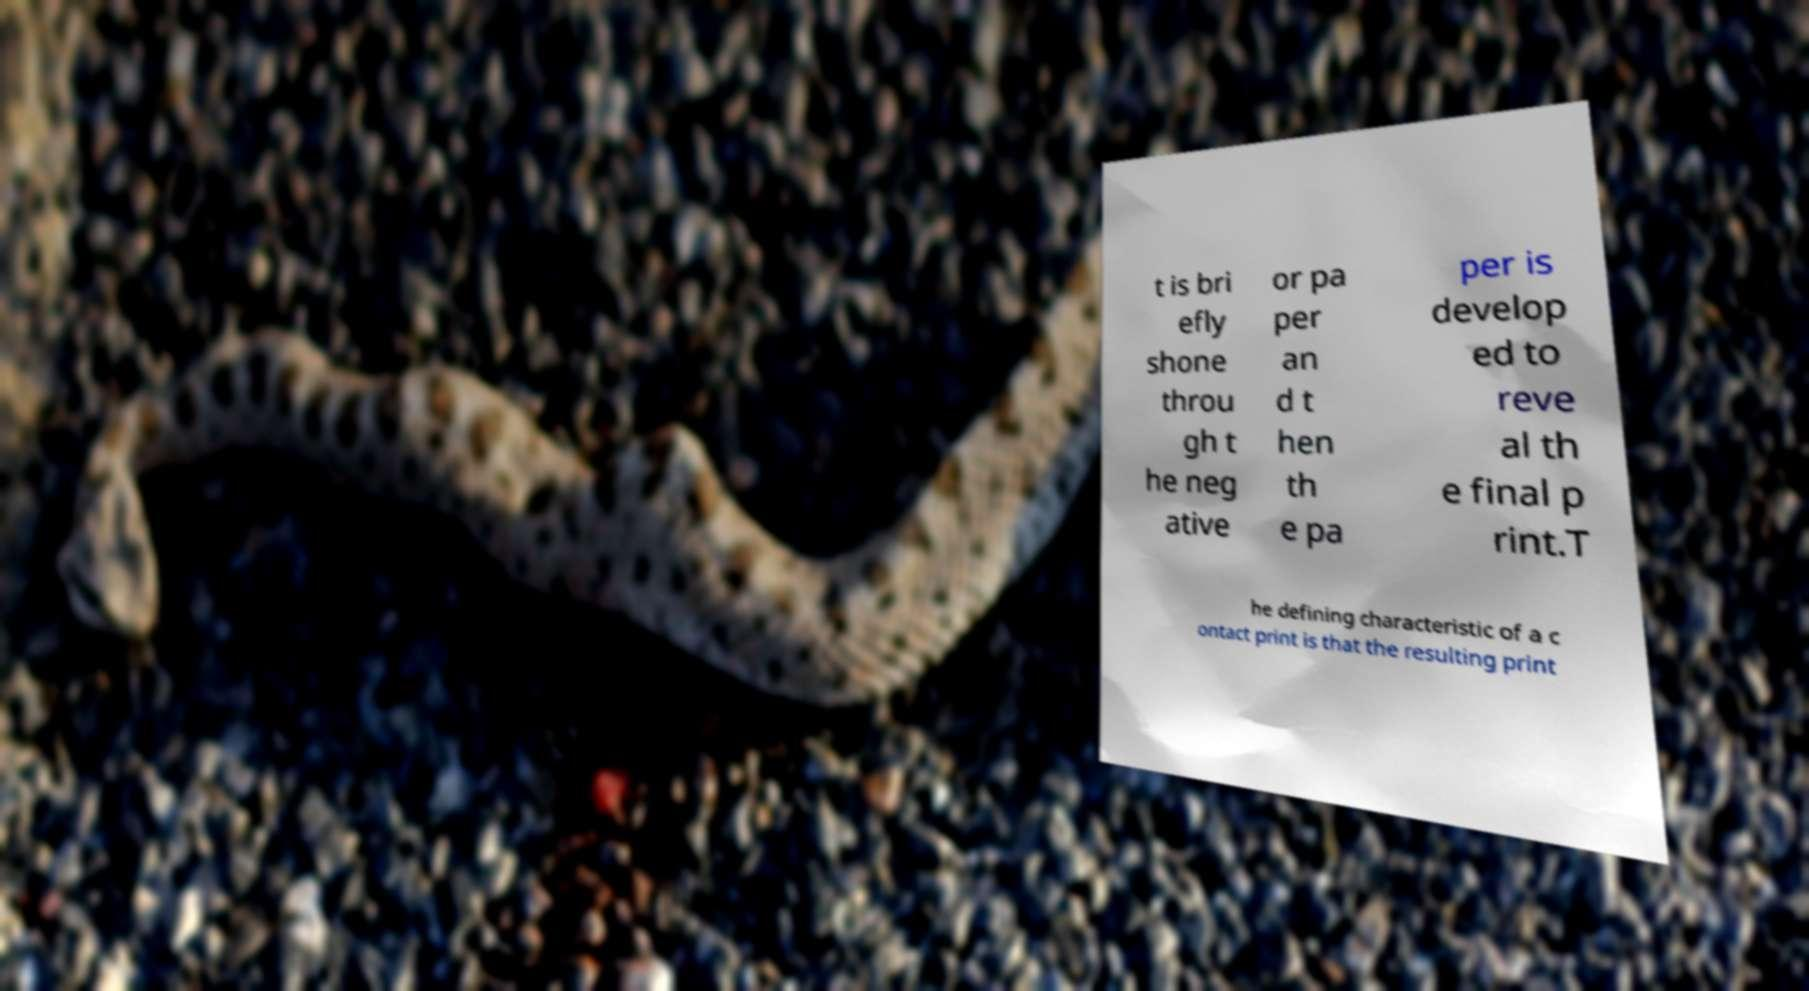There's text embedded in this image that I need extracted. Can you transcribe it verbatim? t is bri efly shone throu gh t he neg ative or pa per an d t hen th e pa per is develop ed to reve al th e final p rint.T he defining characteristic of a c ontact print is that the resulting print 